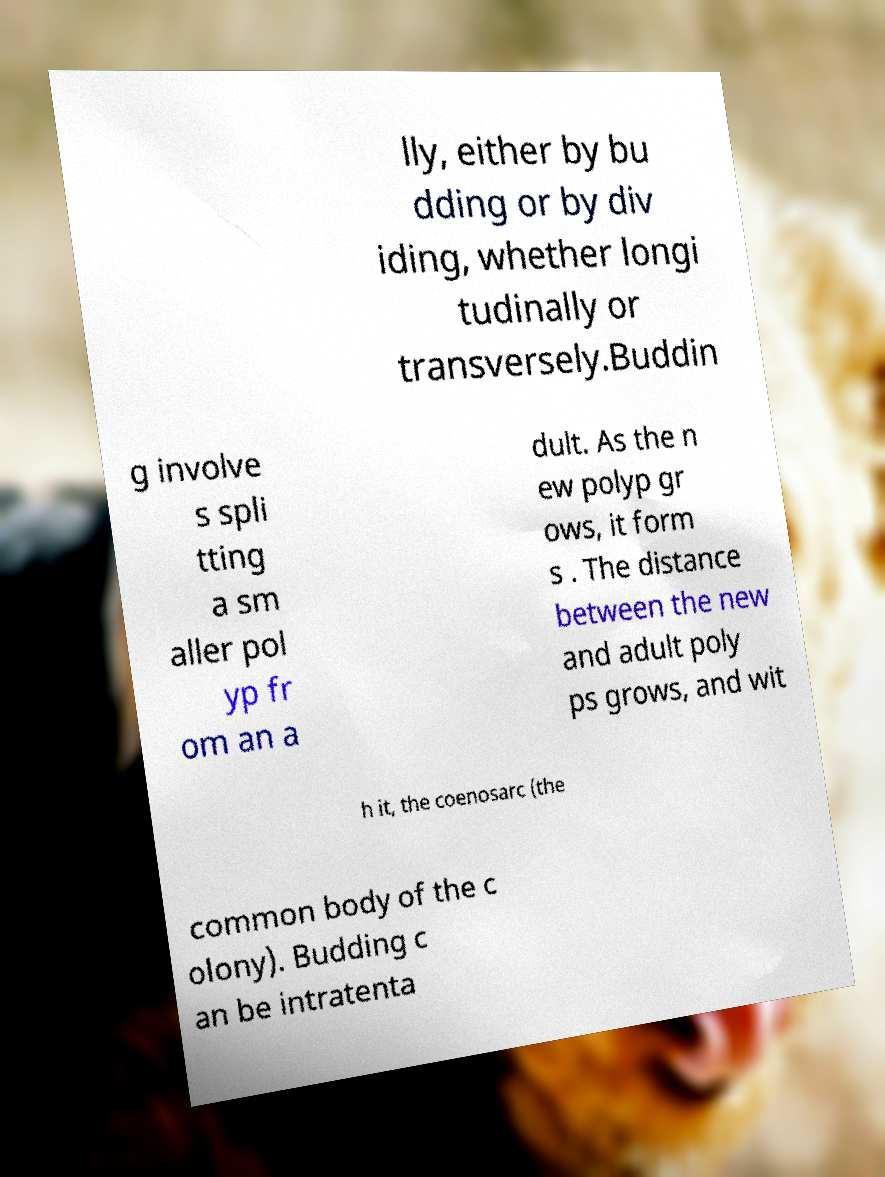Could you assist in decoding the text presented in this image and type it out clearly? lly, either by bu dding or by div iding, whether longi tudinally or transversely.Buddin g involve s spli tting a sm aller pol yp fr om an a dult. As the n ew polyp gr ows, it form s . The distance between the new and adult poly ps grows, and wit h it, the coenosarc (the common body of the c olony). Budding c an be intratenta 